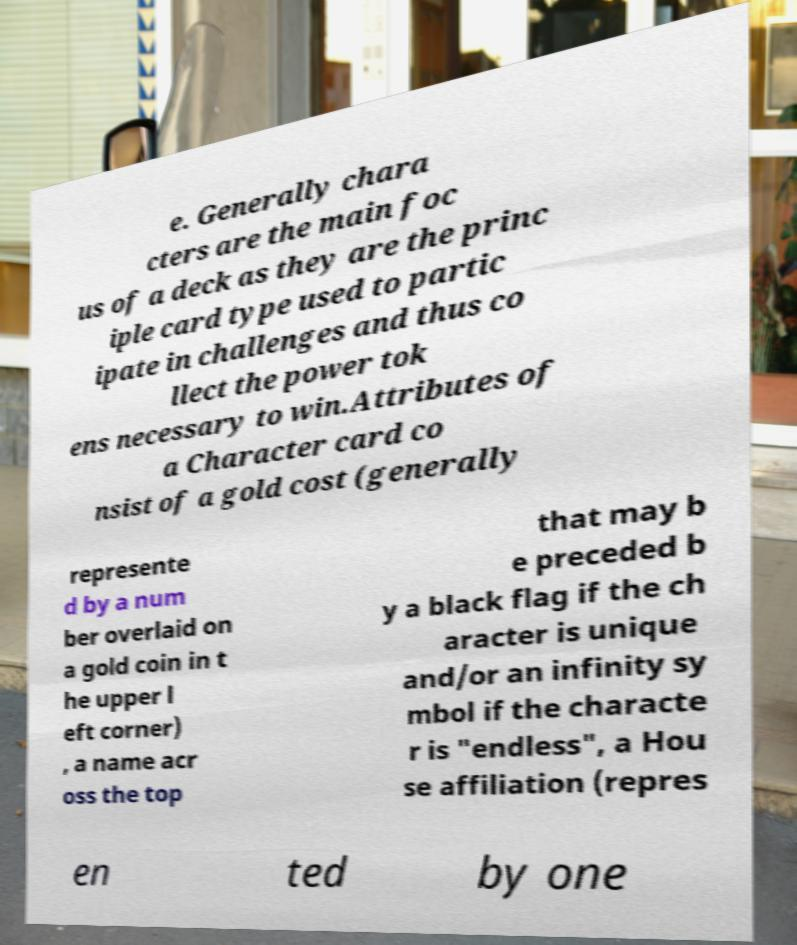I need the written content from this picture converted into text. Can you do that? e. Generally chara cters are the main foc us of a deck as they are the princ iple card type used to partic ipate in challenges and thus co llect the power tok ens necessary to win.Attributes of a Character card co nsist of a gold cost (generally represente d by a num ber overlaid on a gold coin in t he upper l eft corner) , a name acr oss the top that may b e preceded b y a black flag if the ch aracter is unique and/or an infinity sy mbol if the characte r is "endless", a Hou se affiliation (repres en ted by one 